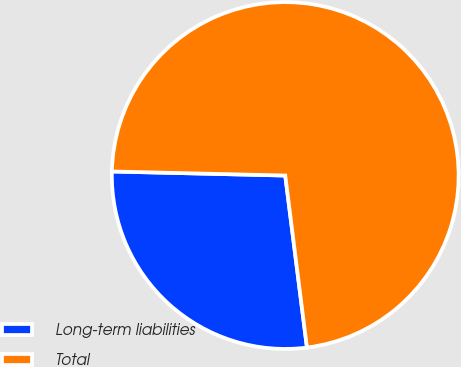Convert chart. <chart><loc_0><loc_0><loc_500><loc_500><pie_chart><fcel>Long-term liabilities<fcel>Total<nl><fcel>27.37%<fcel>72.63%<nl></chart> 